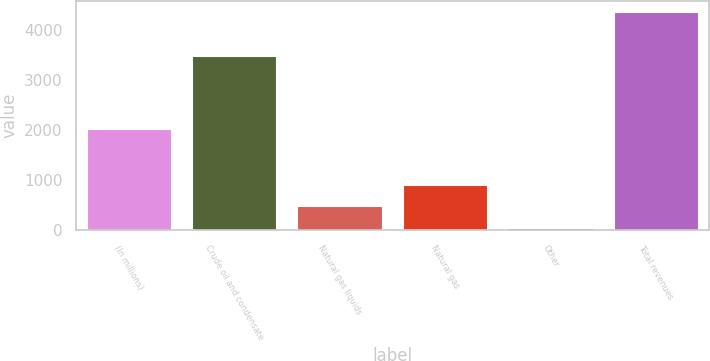Convert chart to OTSL. <chart><loc_0><loc_0><loc_500><loc_500><bar_chart><fcel>(In millions)<fcel>Crude oil and condensate<fcel>Natural gas liquids<fcel>Natural gas<fcel>Other<fcel>Total revenues<nl><fcel>2017<fcel>3477<fcel>480.5<fcel>913<fcel>48<fcel>4373<nl></chart> 